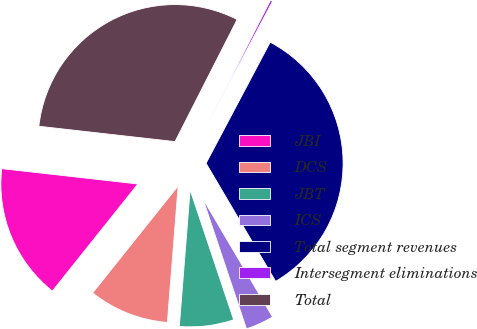Convert chart. <chart><loc_0><loc_0><loc_500><loc_500><pie_chart><fcel>JBI<fcel>DCS<fcel>JBT<fcel>ICS<fcel>Total segment revenues<fcel>Intersegment eliminations<fcel>Total<nl><fcel>16.06%<fcel>9.47%<fcel>6.4%<fcel>3.33%<fcel>33.77%<fcel>0.26%<fcel>30.7%<nl></chart> 